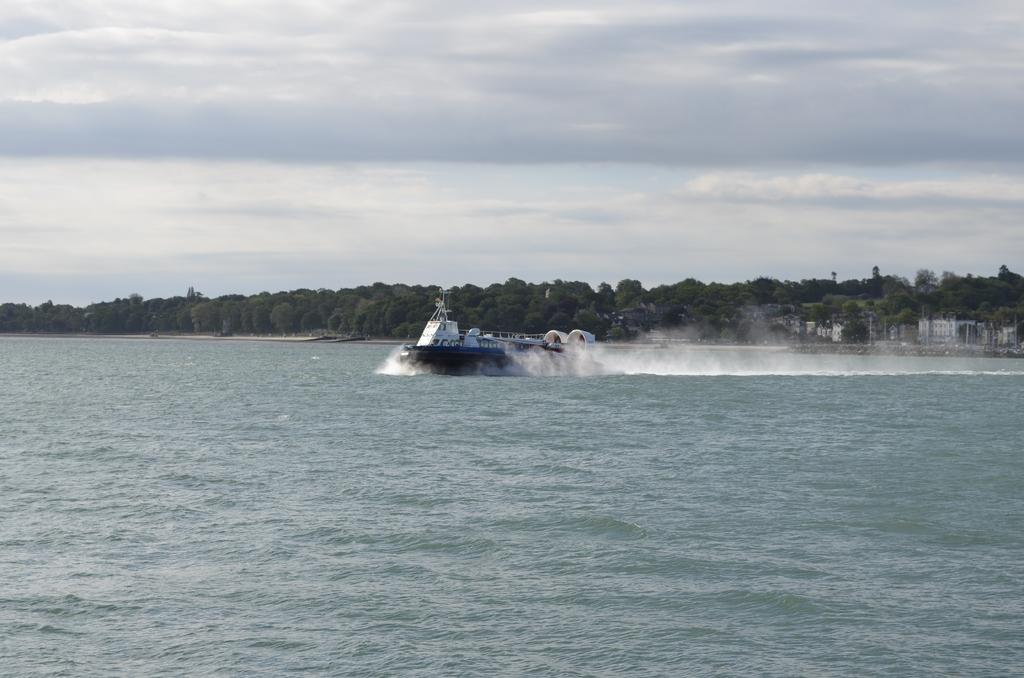What is the main subject of the image? The main subject of the image is a boat. Where is the boat located in the image? The boat is on the surface of the water. What can be seen in the background of the image? There are trees and buildings in the background of the image. What is visible in the sky in the image? The sky is visible in the image, and clouds are present. What type of pipe can be seen being used by the carpenter in the image? There is no carpenter or pipe present in the image; it features a boat on the water with trees, buildings, and clouds in the background. 